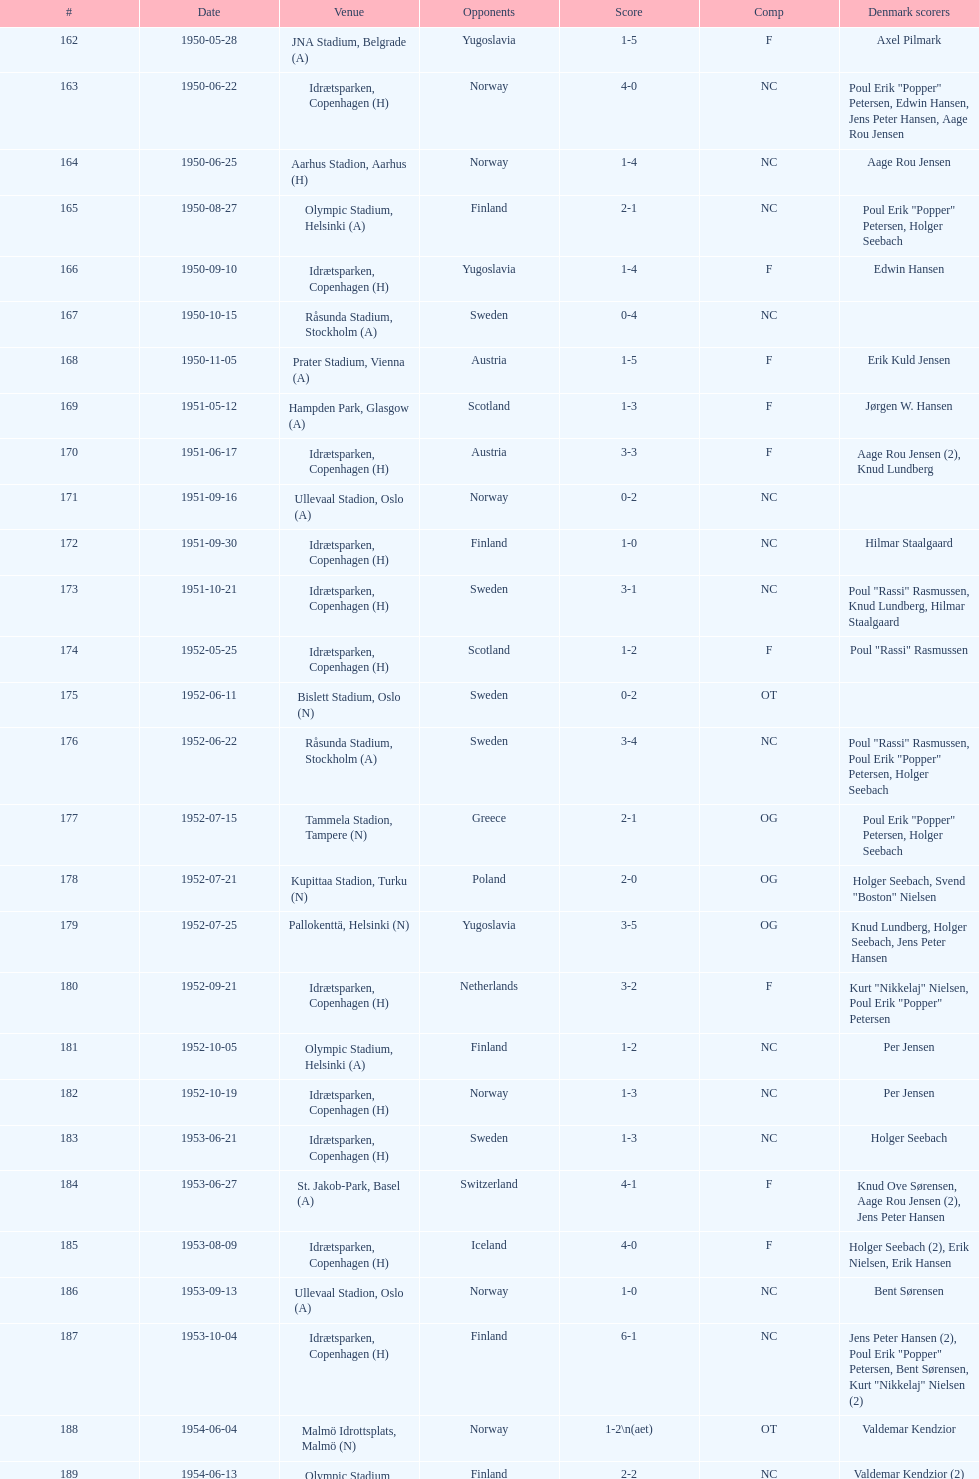In the game that took place immediately prior to july 25, 1952, who were they up against? Poland. 